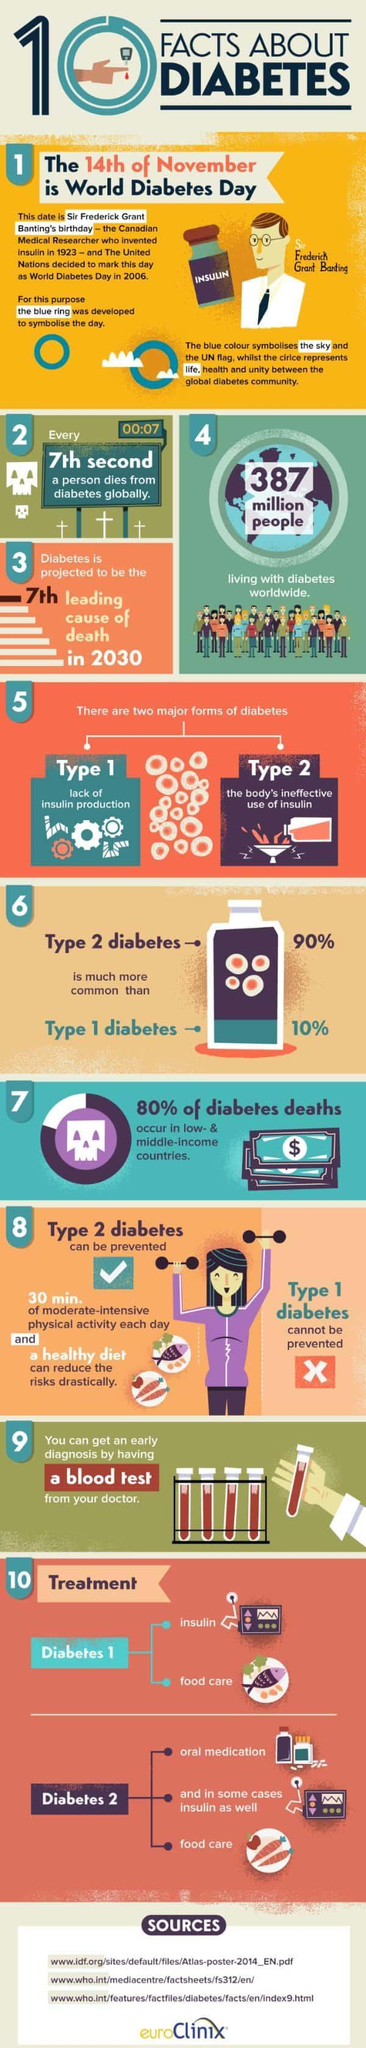What is the total population of diabetic people in the world?
Answer the question with a short phrase. 387 million What percentage of people are not affected by Type 2 diabetes? 10% What is the major cause of Type 2 diabetes? the body's ineffective use of insulin What percentage of people are not affected by Type 1 diabetes? 90% What is the major cause of Type 1 diabetes? lack of insulin production What are the two treatment methods for Type 1 Diabetes? insulin, foodcare 